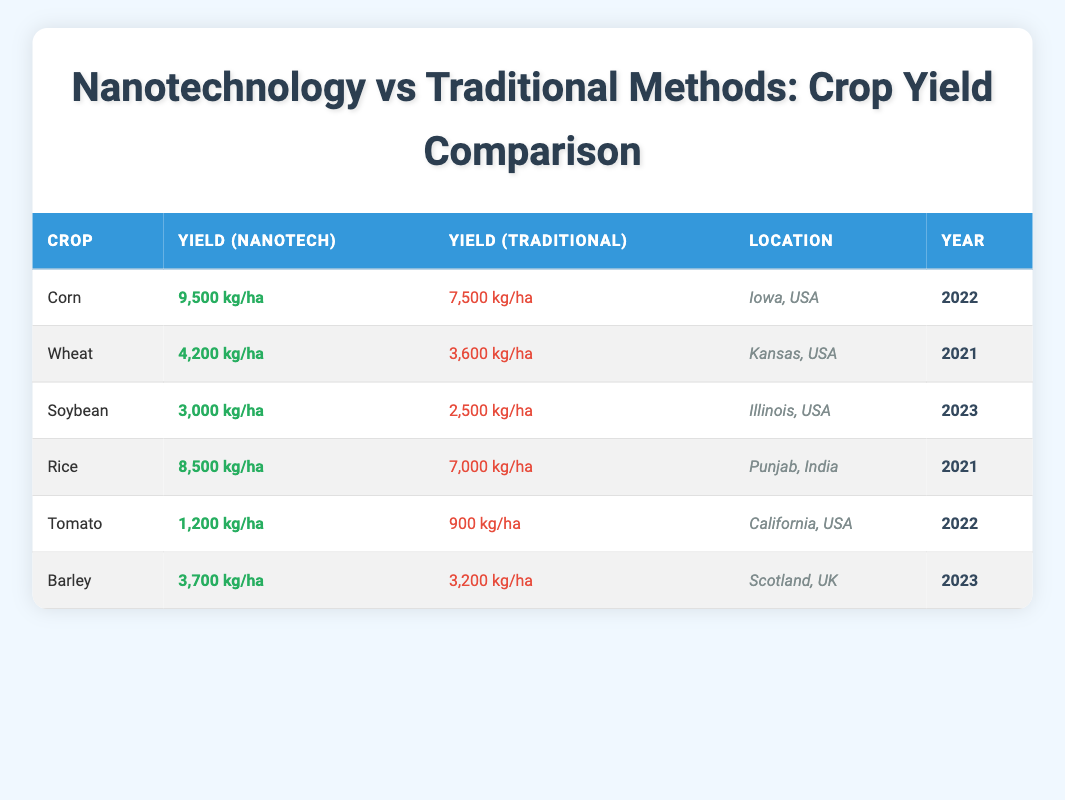What is the highest yield achieved with nanotechnology? The table lists different crops and their respective yields under nanotechnology. Scanning through the "Yield (Nanotech)" column, the maximum value is found for corn with a yield of 9500 kg/ha.
Answer: 9500 kg/ha Which crop had the lowest yield using traditional methods? By examining the "Yield (Traditional)" column, we look for the lowest figure among all crops. The lowest value is for tomato with a yield of 900 kg/ha.
Answer: 900 kg/ha What is the difference in yield between soybean treated with nanotechnology and wheat treated with traditional methods? To find the difference, we need to first identify the yield values from the table. Soybean nanotech yield is 3000 kg/ha and wheat traditional yield is 3600 kg/ha. The difference is calculated as 3000 - 3600 = -600 kg/ha.
Answer: -600 kg/ha In which year was the nanotechnology yield for rice recorded? Referring to the table, we can directly find the year associated with rice's nanotech yield in the "Year" column. It shows rice's yield was recorded in 2021.
Answer: 2021 Is the yield from npanotechnology for barley higher than that of tomato's traditional yield? To verify this, we compare the yield values: Barley nanotech yield is 3700 kg/ha while the traditional yield for tomato is 900 kg/ha. Since 3700 is greater than 900, the statement is true.
Answer: Yes What is the average yield for crops treated with nanotechnology? To calculate the average, we need to sum all the yield values from the "Yield (Nanotech)" column, which are 9500, 4200, 3000, 8500, 1200, and 3700 kg/ha. The total is 9500 + 4200 + 3000 + 8500 + 1200 + 3700 = 30600 kg/ha. Since there are 6 crops, the average yield is 30600 / 6 = 5100 kg/ha.
Answer: 5100 kg/ha How much more yield does corn produce with nanotechnology compared to wheat with traditional methods? First, we find corn's yield with nanotechnology, which is 9500 kg/ha, and wheat's yield with traditional methods, which is 3600 kg/ha. The difference is then calculated as 9500 - 3600 = 5900 kg/ha.
Answer: 5900 kg/ha Which location had the highest crop yield using traditional methods? We look for the maximum value in the "Yield (Traditional)" column. The highest value is for wheat with a traditional yield of 3600 kg/ha, located in Kansas, USA. Thus, Kansas has the highest traditional yield among the crops listed.
Answer: Kansas, USA 